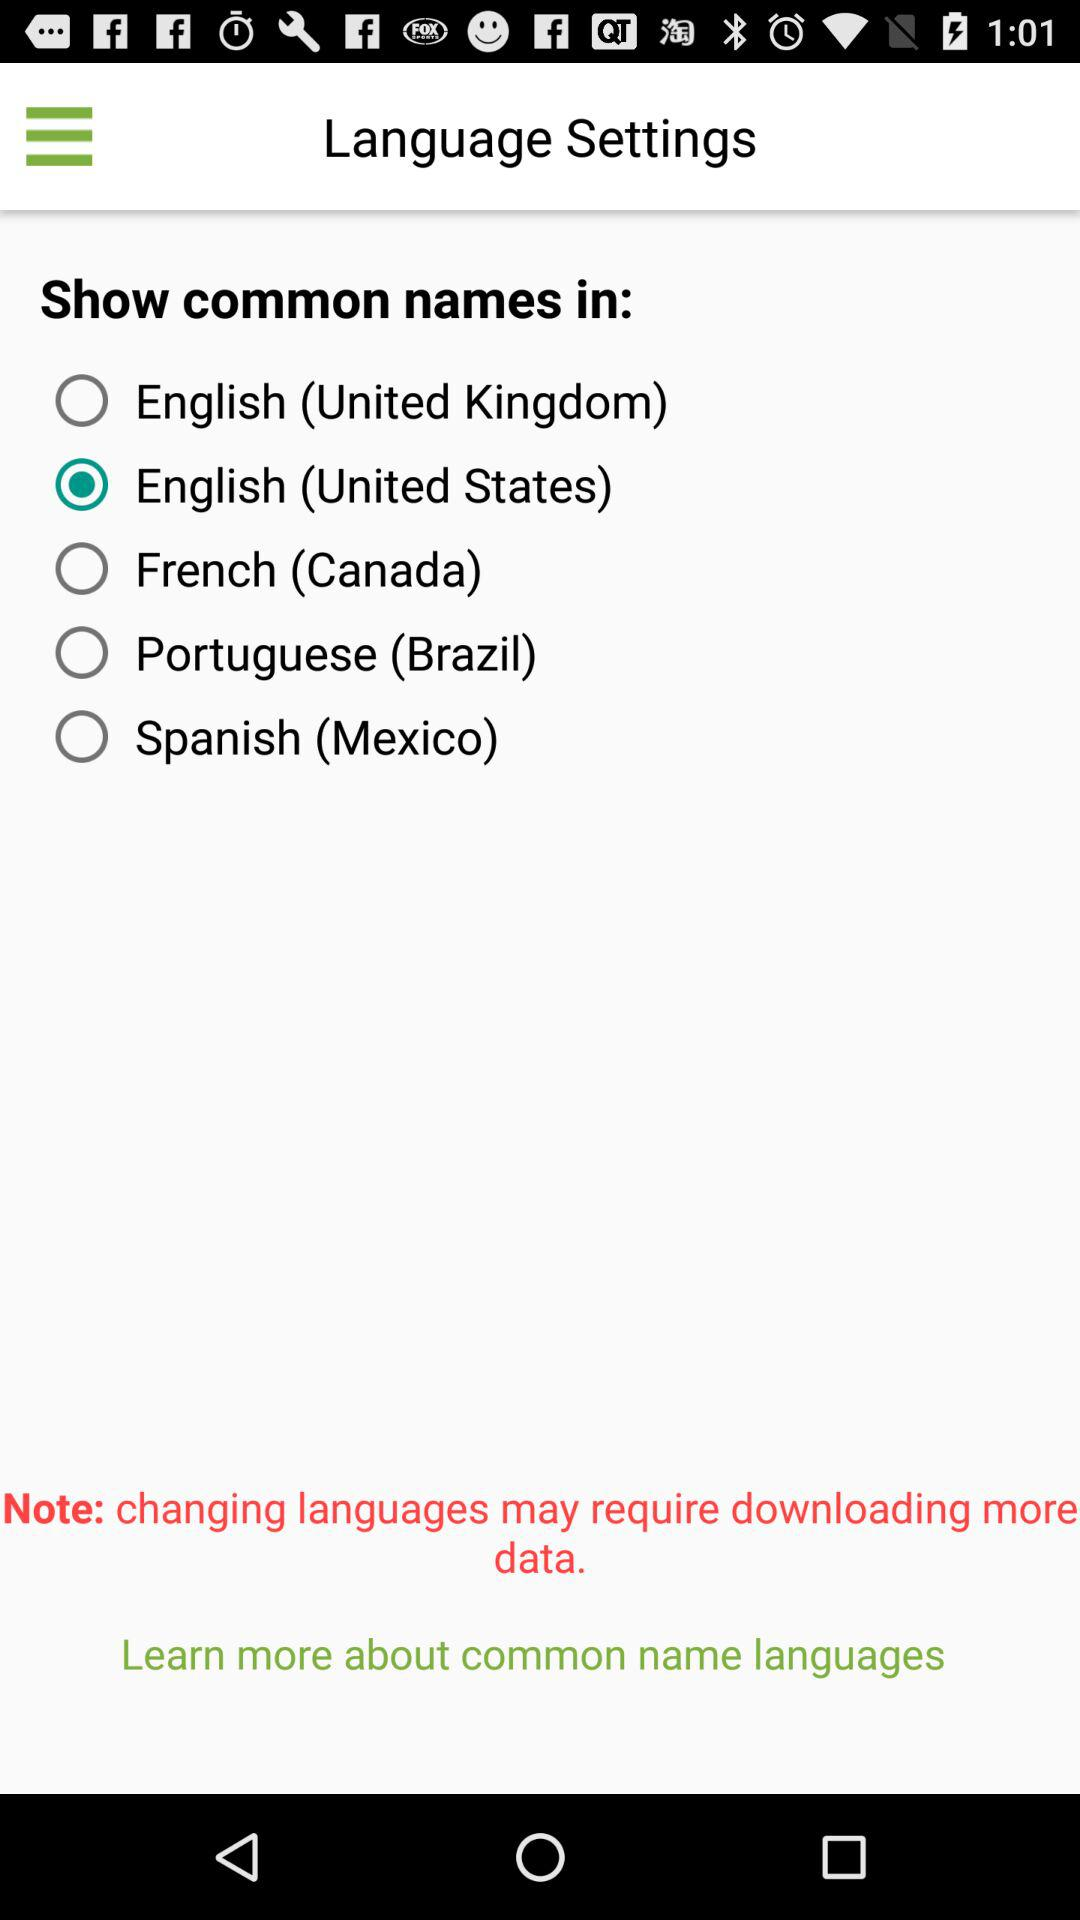Which is the selected option? The selected option is "English (United States)". 